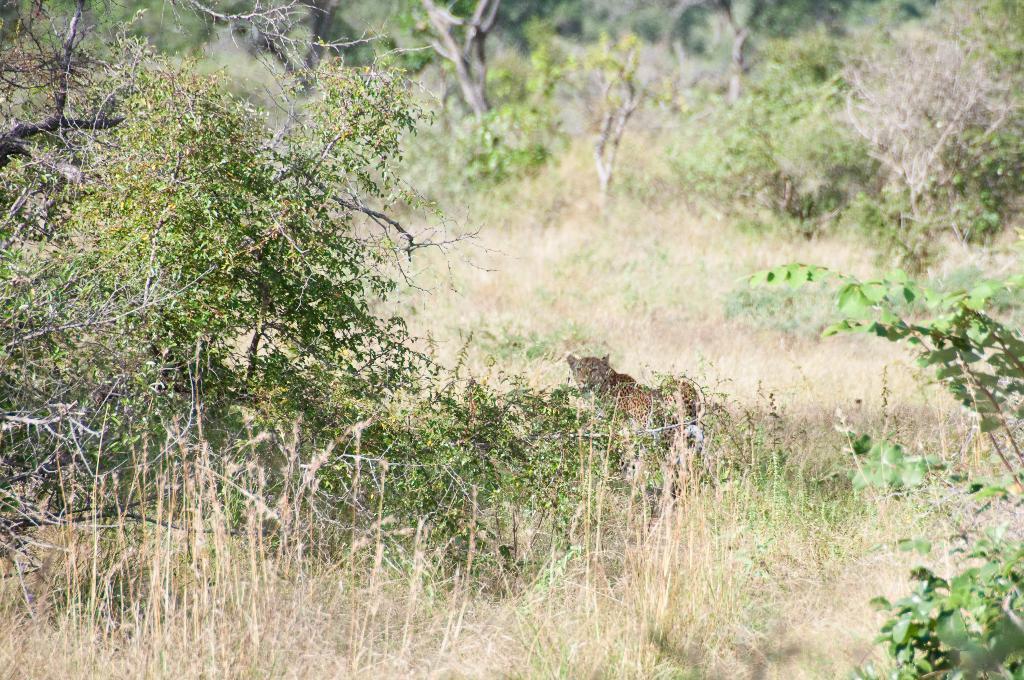Can you describe this image briefly? In the center of the image we can see a cheetah. In the background of the image we can see the trees and grass. 